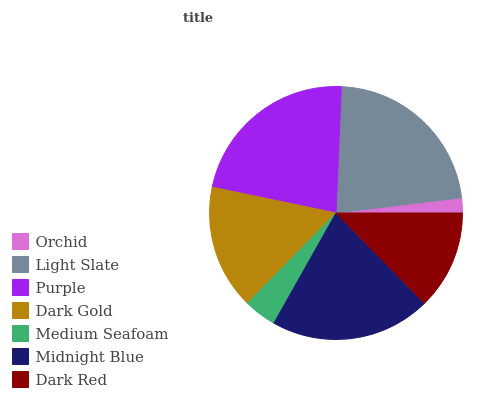Is Orchid the minimum?
Answer yes or no. Yes. Is Light Slate the maximum?
Answer yes or no. Yes. Is Purple the minimum?
Answer yes or no. No. Is Purple the maximum?
Answer yes or no. No. Is Light Slate greater than Purple?
Answer yes or no. Yes. Is Purple less than Light Slate?
Answer yes or no. Yes. Is Purple greater than Light Slate?
Answer yes or no. No. Is Light Slate less than Purple?
Answer yes or no. No. Is Dark Gold the high median?
Answer yes or no. Yes. Is Dark Gold the low median?
Answer yes or no. Yes. Is Orchid the high median?
Answer yes or no. No. Is Purple the low median?
Answer yes or no. No. 